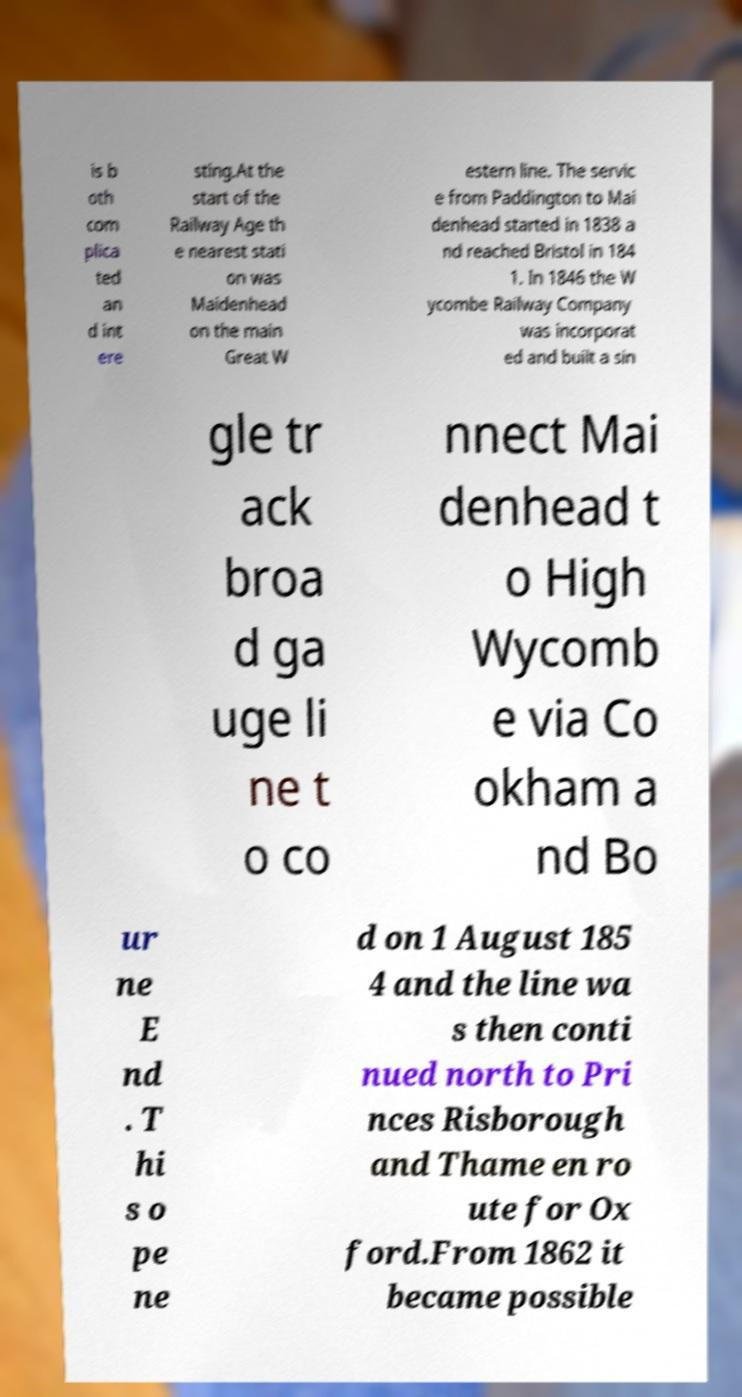There's text embedded in this image that I need extracted. Can you transcribe it verbatim? is b oth com plica ted an d int ere sting.At the start of the Railway Age th e nearest stati on was Maidenhead on the main Great W estern line. The servic e from Paddington to Mai denhead started in 1838 a nd reached Bristol in 184 1. In 1846 the W ycombe Railway Company was incorporat ed and built a sin gle tr ack broa d ga uge li ne t o co nnect Mai denhead t o High Wycomb e via Co okham a nd Bo ur ne E nd . T hi s o pe ne d on 1 August 185 4 and the line wa s then conti nued north to Pri nces Risborough and Thame en ro ute for Ox ford.From 1862 it became possible 